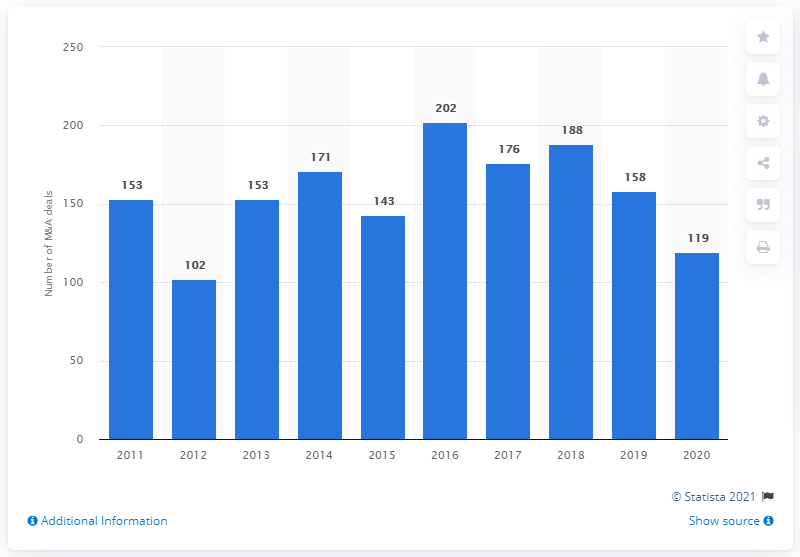List a handful of essential elements in this visual. In 2016, a total of 202 M&A deals were completed. In 2012, a total of 102 deals were completed. 